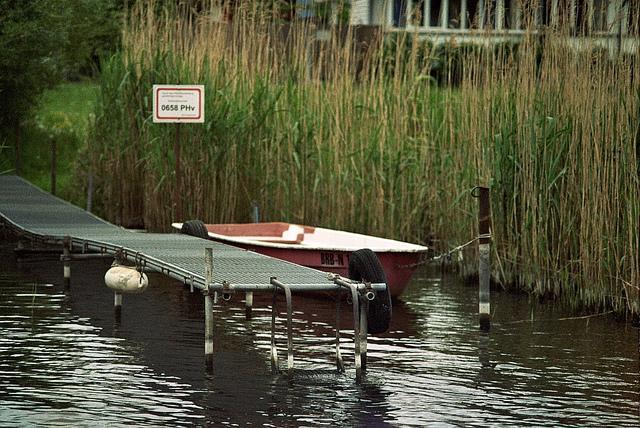How many tires are in the picture?
Give a very brief answer. 2. 